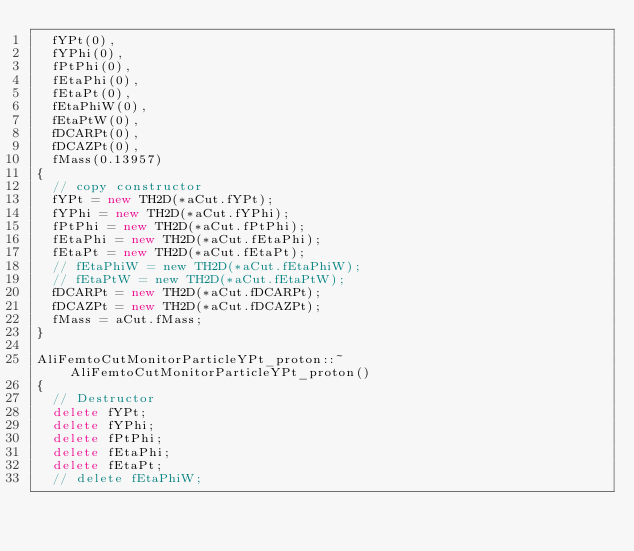Convert code to text. <code><loc_0><loc_0><loc_500><loc_500><_C++_>  fYPt(0),
  fYPhi(0),
  fPtPhi(0),
  fEtaPhi(0),
  fEtaPt(0),
  fEtaPhiW(0),
  fEtaPtW(0),
  fDCARPt(0),
  fDCAZPt(0),
  fMass(0.13957)
{
  // copy constructor
  fYPt = new TH2D(*aCut.fYPt);
  fYPhi = new TH2D(*aCut.fYPhi);
  fPtPhi = new TH2D(*aCut.fPtPhi);
  fEtaPhi = new TH2D(*aCut.fEtaPhi);
  fEtaPt = new TH2D(*aCut.fEtaPt);
  // fEtaPhiW = new TH2D(*aCut.fEtaPhiW);
  // fEtaPtW = new TH2D(*aCut.fEtaPtW);
  fDCARPt = new TH2D(*aCut.fDCARPt);
  fDCAZPt = new TH2D(*aCut.fDCAZPt);
  fMass = aCut.fMass; 
}

AliFemtoCutMonitorParticleYPt_proton::~AliFemtoCutMonitorParticleYPt_proton()
{
  // Destructor
  delete fYPt;
  delete fYPhi;
  delete fPtPhi;
  delete fEtaPhi;
  delete fEtaPt;
  // delete fEtaPhiW;</code> 